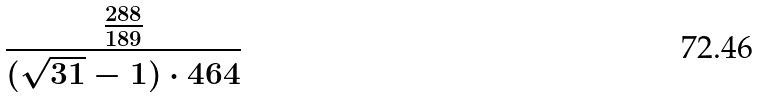<formula> <loc_0><loc_0><loc_500><loc_500>\frac { \frac { 2 8 8 } { 1 8 9 } } { ( \sqrt { 3 1 } - 1 ) \cdot 4 6 4 }</formula> 